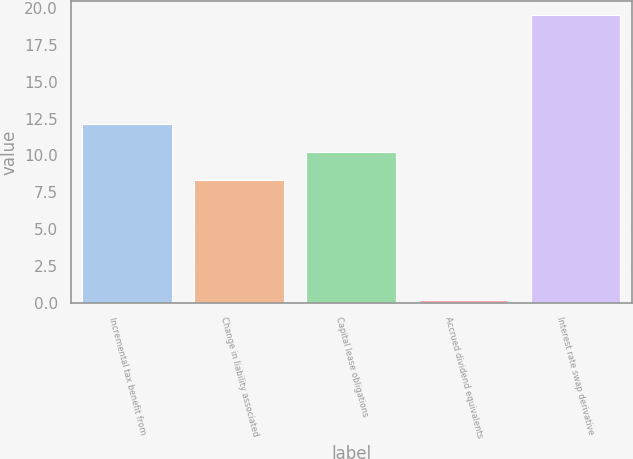Convert chart. <chart><loc_0><loc_0><loc_500><loc_500><bar_chart><fcel>Incremental tax benefit from<fcel>Change in liability associated<fcel>Capital lease obligations<fcel>Accrued dividend equivalents<fcel>Interest rate swap derivative<nl><fcel>12.16<fcel>8.3<fcel>10.23<fcel>0.2<fcel>19.5<nl></chart> 